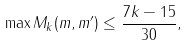<formula> <loc_0><loc_0><loc_500><loc_500>\max M _ { k } ( m , m ^ { \prime } ) \leq \frac { 7 k - 1 5 } { 3 0 } ,</formula> 